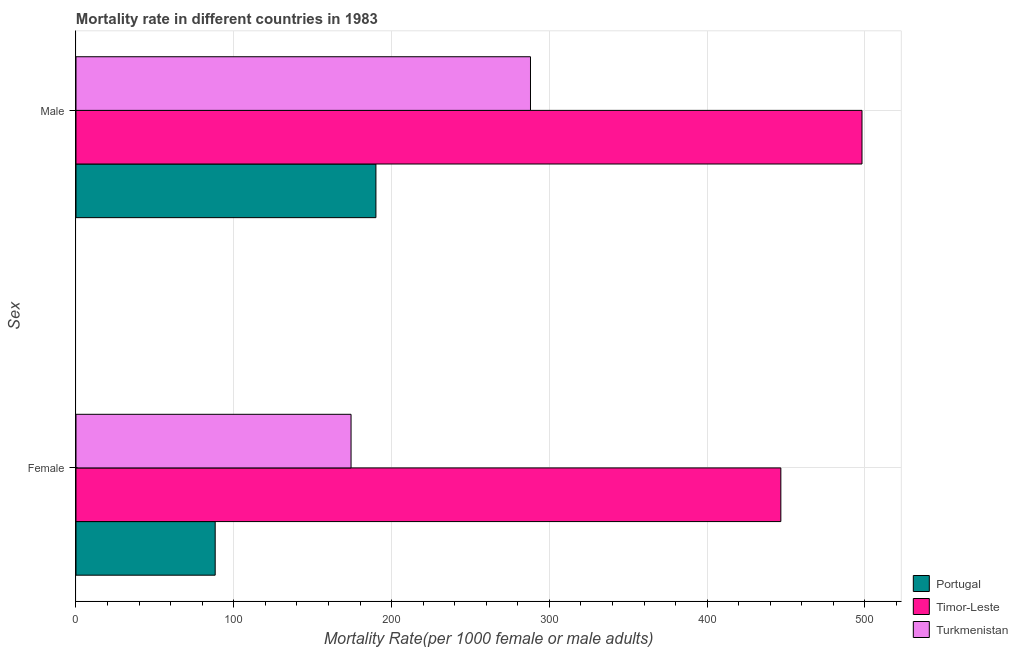How many groups of bars are there?
Your response must be concise. 2. What is the female mortality rate in Portugal?
Ensure brevity in your answer.  88.22. Across all countries, what is the maximum male mortality rate?
Your answer should be compact. 498.15. Across all countries, what is the minimum female mortality rate?
Provide a short and direct response. 88.22. In which country was the male mortality rate maximum?
Your answer should be compact. Timor-Leste. In which country was the female mortality rate minimum?
Your response must be concise. Portugal. What is the total female mortality rate in the graph?
Ensure brevity in your answer.  709.25. What is the difference between the male mortality rate in Portugal and that in Timor-Leste?
Provide a short and direct response. -308.06. What is the difference between the male mortality rate in Timor-Leste and the female mortality rate in Portugal?
Your answer should be very brief. 409.93. What is the average female mortality rate per country?
Ensure brevity in your answer.  236.42. What is the difference between the female mortality rate and male mortality rate in Timor-Leste?
Provide a short and direct response. -51.44. In how many countries, is the male mortality rate greater than 280 ?
Your response must be concise. 2. What is the ratio of the female mortality rate in Timor-Leste to that in Portugal?
Offer a terse response. 5.06. In how many countries, is the male mortality rate greater than the average male mortality rate taken over all countries?
Ensure brevity in your answer.  1. What does the 2nd bar from the bottom in Female represents?
Ensure brevity in your answer.  Timor-Leste. Are all the bars in the graph horizontal?
Keep it short and to the point. Yes. Does the graph contain any zero values?
Provide a short and direct response. No. How many legend labels are there?
Give a very brief answer. 3. How are the legend labels stacked?
Provide a succinct answer. Vertical. What is the title of the graph?
Your response must be concise. Mortality rate in different countries in 1983. What is the label or title of the X-axis?
Give a very brief answer. Mortality Rate(per 1000 female or male adults). What is the label or title of the Y-axis?
Provide a succinct answer. Sex. What is the Mortality Rate(per 1000 female or male adults) in Portugal in Female?
Provide a short and direct response. 88.22. What is the Mortality Rate(per 1000 female or male adults) of Timor-Leste in Female?
Your answer should be very brief. 446.71. What is the Mortality Rate(per 1000 female or male adults) in Turkmenistan in Female?
Your answer should be very brief. 174.33. What is the Mortality Rate(per 1000 female or male adults) of Portugal in Male?
Offer a very short reply. 190.09. What is the Mortality Rate(per 1000 female or male adults) in Timor-Leste in Male?
Offer a very short reply. 498.15. What is the Mortality Rate(per 1000 female or male adults) of Turkmenistan in Male?
Your answer should be very brief. 288.05. Across all Sex, what is the maximum Mortality Rate(per 1000 female or male adults) of Portugal?
Offer a very short reply. 190.09. Across all Sex, what is the maximum Mortality Rate(per 1000 female or male adults) in Timor-Leste?
Your answer should be compact. 498.15. Across all Sex, what is the maximum Mortality Rate(per 1000 female or male adults) in Turkmenistan?
Your answer should be compact. 288.05. Across all Sex, what is the minimum Mortality Rate(per 1000 female or male adults) in Portugal?
Give a very brief answer. 88.22. Across all Sex, what is the minimum Mortality Rate(per 1000 female or male adults) in Timor-Leste?
Give a very brief answer. 446.71. Across all Sex, what is the minimum Mortality Rate(per 1000 female or male adults) of Turkmenistan?
Make the answer very short. 174.33. What is the total Mortality Rate(per 1000 female or male adults) of Portugal in the graph?
Offer a terse response. 278.31. What is the total Mortality Rate(per 1000 female or male adults) in Timor-Leste in the graph?
Offer a very short reply. 944.86. What is the total Mortality Rate(per 1000 female or male adults) in Turkmenistan in the graph?
Offer a terse response. 462.37. What is the difference between the Mortality Rate(per 1000 female or male adults) of Portugal in Female and that in Male?
Ensure brevity in your answer.  -101.87. What is the difference between the Mortality Rate(per 1000 female or male adults) of Timor-Leste in Female and that in Male?
Keep it short and to the point. -51.44. What is the difference between the Mortality Rate(per 1000 female or male adults) of Turkmenistan in Female and that in Male?
Your response must be concise. -113.72. What is the difference between the Mortality Rate(per 1000 female or male adults) of Portugal in Female and the Mortality Rate(per 1000 female or male adults) of Timor-Leste in Male?
Give a very brief answer. -409.93. What is the difference between the Mortality Rate(per 1000 female or male adults) in Portugal in Female and the Mortality Rate(per 1000 female or male adults) in Turkmenistan in Male?
Keep it short and to the point. -199.83. What is the difference between the Mortality Rate(per 1000 female or male adults) of Timor-Leste in Female and the Mortality Rate(per 1000 female or male adults) of Turkmenistan in Male?
Offer a terse response. 158.66. What is the average Mortality Rate(per 1000 female or male adults) in Portugal per Sex?
Your response must be concise. 139.15. What is the average Mortality Rate(per 1000 female or male adults) in Timor-Leste per Sex?
Provide a succinct answer. 472.43. What is the average Mortality Rate(per 1000 female or male adults) in Turkmenistan per Sex?
Your answer should be compact. 231.19. What is the difference between the Mortality Rate(per 1000 female or male adults) of Portugal and Mortality Rate(per 1000 female or male adults) of Timor-Leste in Female?
Offer a very short reply. -358.49. What is the difference between the Mortality Rate(per 1000 female or male adults) in Portugal and Mortality Rate(per 1000 female or male adults) in Turkmenistan in Female?
Ensure brevity in your answer.  -86.11. What is the difference between the Mortality Rate(per 1000 female or male adults) in Timor-Leste and Mortality Rate(per 1000 female or male adults) in Turkmenistan in Female?
Keep it short and to the point. 272.38. What is the difference between the Mortality Rate(per 1000 female or male adults) of Portugal and Mortality Rate(per 1000 female or male adults) of Timor-Leste in Male?
Keep it short and to the point. -308.06. What is the difference between the Mortality Rate(per 1000 female or male adults) in Portugal and Mortality Rate(per 1000 female or male adults) in Turkmenistan in Male?
Offer a terse response. -97.96. What is the difference between the Mortality Rate(per 1000 female or male adults) in Timor-Leste and Mortality Rate(per 1000 female or male adults) in Turkmenistan in Male?
Your answer should be compact. 210.1. What is the ratio of the Mortality Rate(per 1000 female or male adults) in Portugal in Female to that in Male?
Provide a short and direct response. 0.46. What is the ratio of the Mortality Rate(per 1000 female or male adults) in Timor-Leste in Female to that in Male?
Give a very brief answer. 0.9. What is the ratio of the Mortality Rate(per 1000 female or male adults) in Turkmenistan in Female to that in Male?
Give a very brief answer. 0.61. What is the difference between the highest and the second highest Mortality Rate(per 1000 female or male adults) in Portugal?
Offer a terse response. 101.87. What is the difference between the highest and the second highest Mortality Rate(per 1000 female or male adults) of Timor-Leste?
Offer a very short reply. 51.44. What is the difference between the highest and the second highest Mortality Rate(per 1000 female or male adults) of Turkmenistan?
Offer a terse response. 113.72. What is the difference between the highest and the lowest Mortality Rate(per 1000 female or male adults) in Portugal?
Your answer should be compact. 101.87. What is the difference between the highest and the lowest Mortality Rate(per 1000 female or male adults) in Timor-Leste?
Offer a very short reply. 51.44. What is the difference between the highest and the lowest Mortality Rate(per 1000 female or male adults) in Turkmenistan?
Provide a succinct answer. 113.72. 